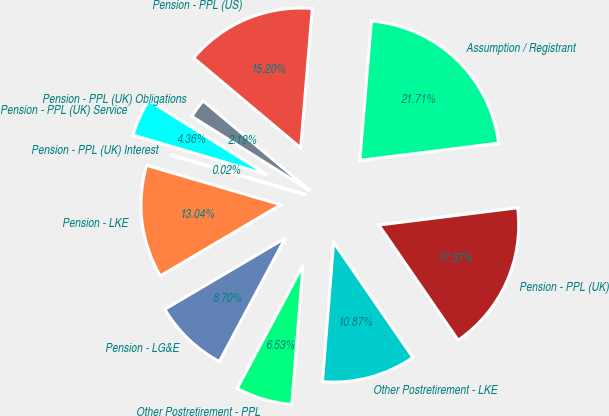Convert chart. <chart><loc_0><loc_0><loc_500><loc_500><pie_chart><fcel>Assumption / Registrant<fcel>Pension - PPL (US)<fcel>Pension - PPL (UK) Obligations<fcel>Pension - PPL (UK) Service<fcel>Pension - PPL (UK) Interest<fcel>Pension - LKE<fcel>Pension - LG&E<fcel>Other Postretirement - PPL<fcel>Other Postretirement - LKE<fcel>Pension - PPL (UK)<nl><fcel>21.71%<fcel>15.2%<fcel>2.19%<fcel>4.36%<fcel>0.02%<fcel>13.04%<fcel>8.7%<fcel>6.53%<fcel>10.87%<fcel>17.37%<nl></chart> 